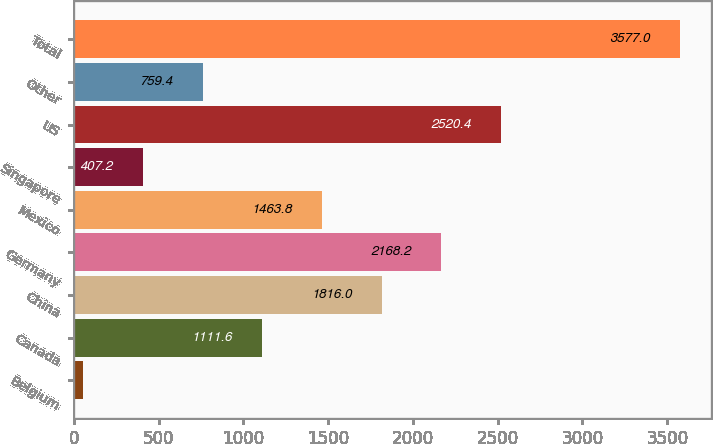Convert chart to OTSL. <chart><loc_0><loc_0><loc_500><loc_500><bar_chart><fcel>Belgium<fcel>Canada<fcel>China<fcel>Germany<fcel>Mexico<fcel>Singapore<fcel>US<fcel>Other<fcel>Total<nl><fcel>55<fcel>1111.6<fcel>1816<fcel>2168.2<fcel>1463.8<fcel>407.2<fcel>2520.4<fcel>759.4<fcel>3577<nl></chart> 